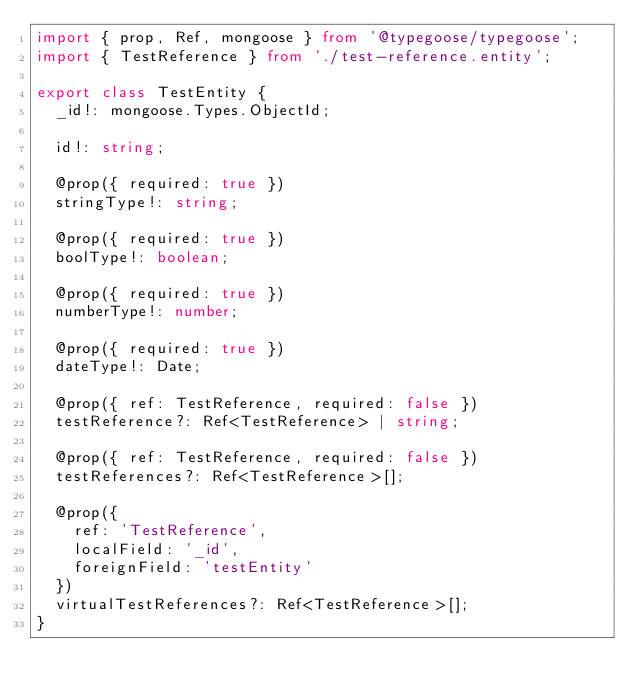Convert code to text. <code><loc_0><loc_0><loc_500><loc_500><_TypeScript_>import { prop, Ref, mongoose } from '@typegoose/typegoose';
import { TestReference } from './test-reference.entity';

export class TestEntity {
  _id!: mongoose.Types.ObjectId;

  id!: string;

  @prop({ required: true })
  stringType!: string;

  @prop({ required: true })
  boolType!: boolean;

  @prop({ required: true })
  numberType!: number;

  @prop({ required: true })
  dateType!: Date;

  @prop({ ref: TestReference, required: false })
  testReference?: Ref<TestReference> | string;

  @prop({ ref: TestReference, required: false })
  testReferences?: Ref<TestReference>[];

  @prop({
    ref: 'TestReference',
    localField: '_id',
    foreignField: 'testEntity'
  })
  virtualTestReferences?: Ref<TestReference>[];
}
</code> 